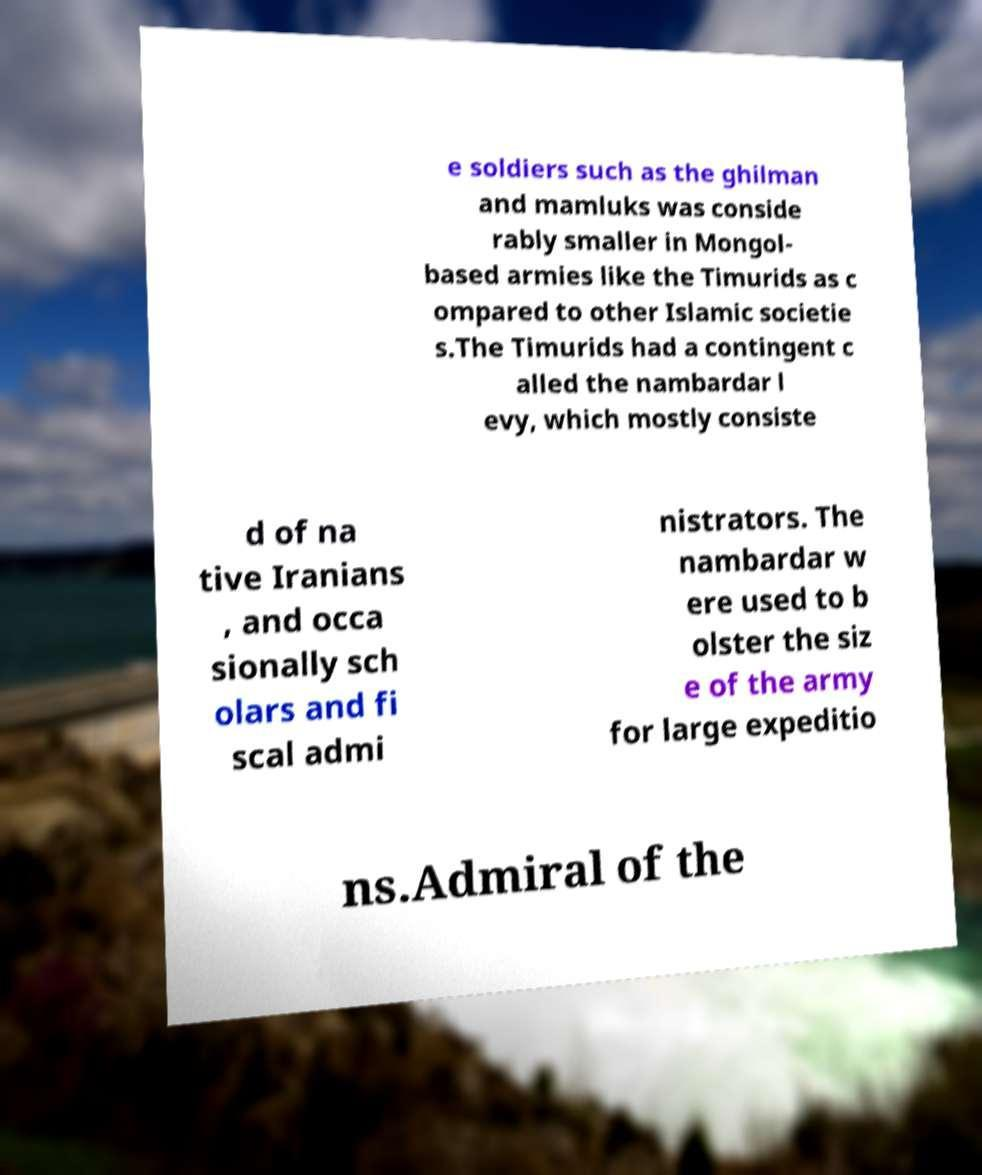Could you extract and type out the text from this image? e soldiers such as the ghilman and mamluks was conside rably smaller in Mongol- based armies like the Timurids as c ompared to other Islamic societie s.The Timurids had a contingent c alled the nambardar l evy, which mostly consiste d of na tive Iranians , and occa sionally sch olars and fi scal admi nistrators. The nambardar w ere used to b olster the siz e of the army for large expeditio ns.Admiral of the 